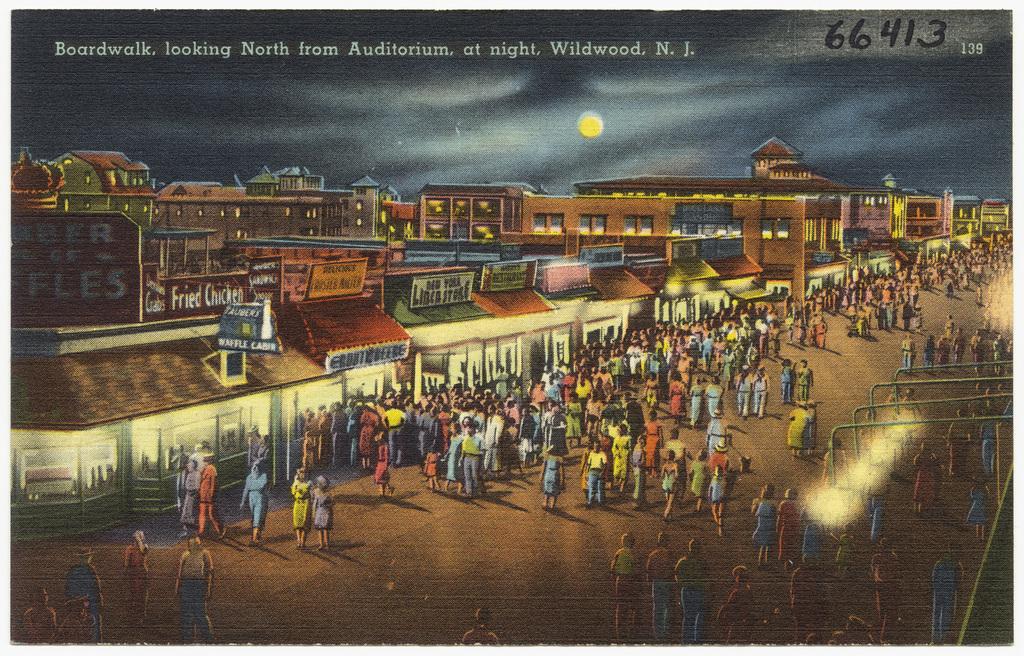What is the left store?
Keep it short and to the point. Fried chicken. 